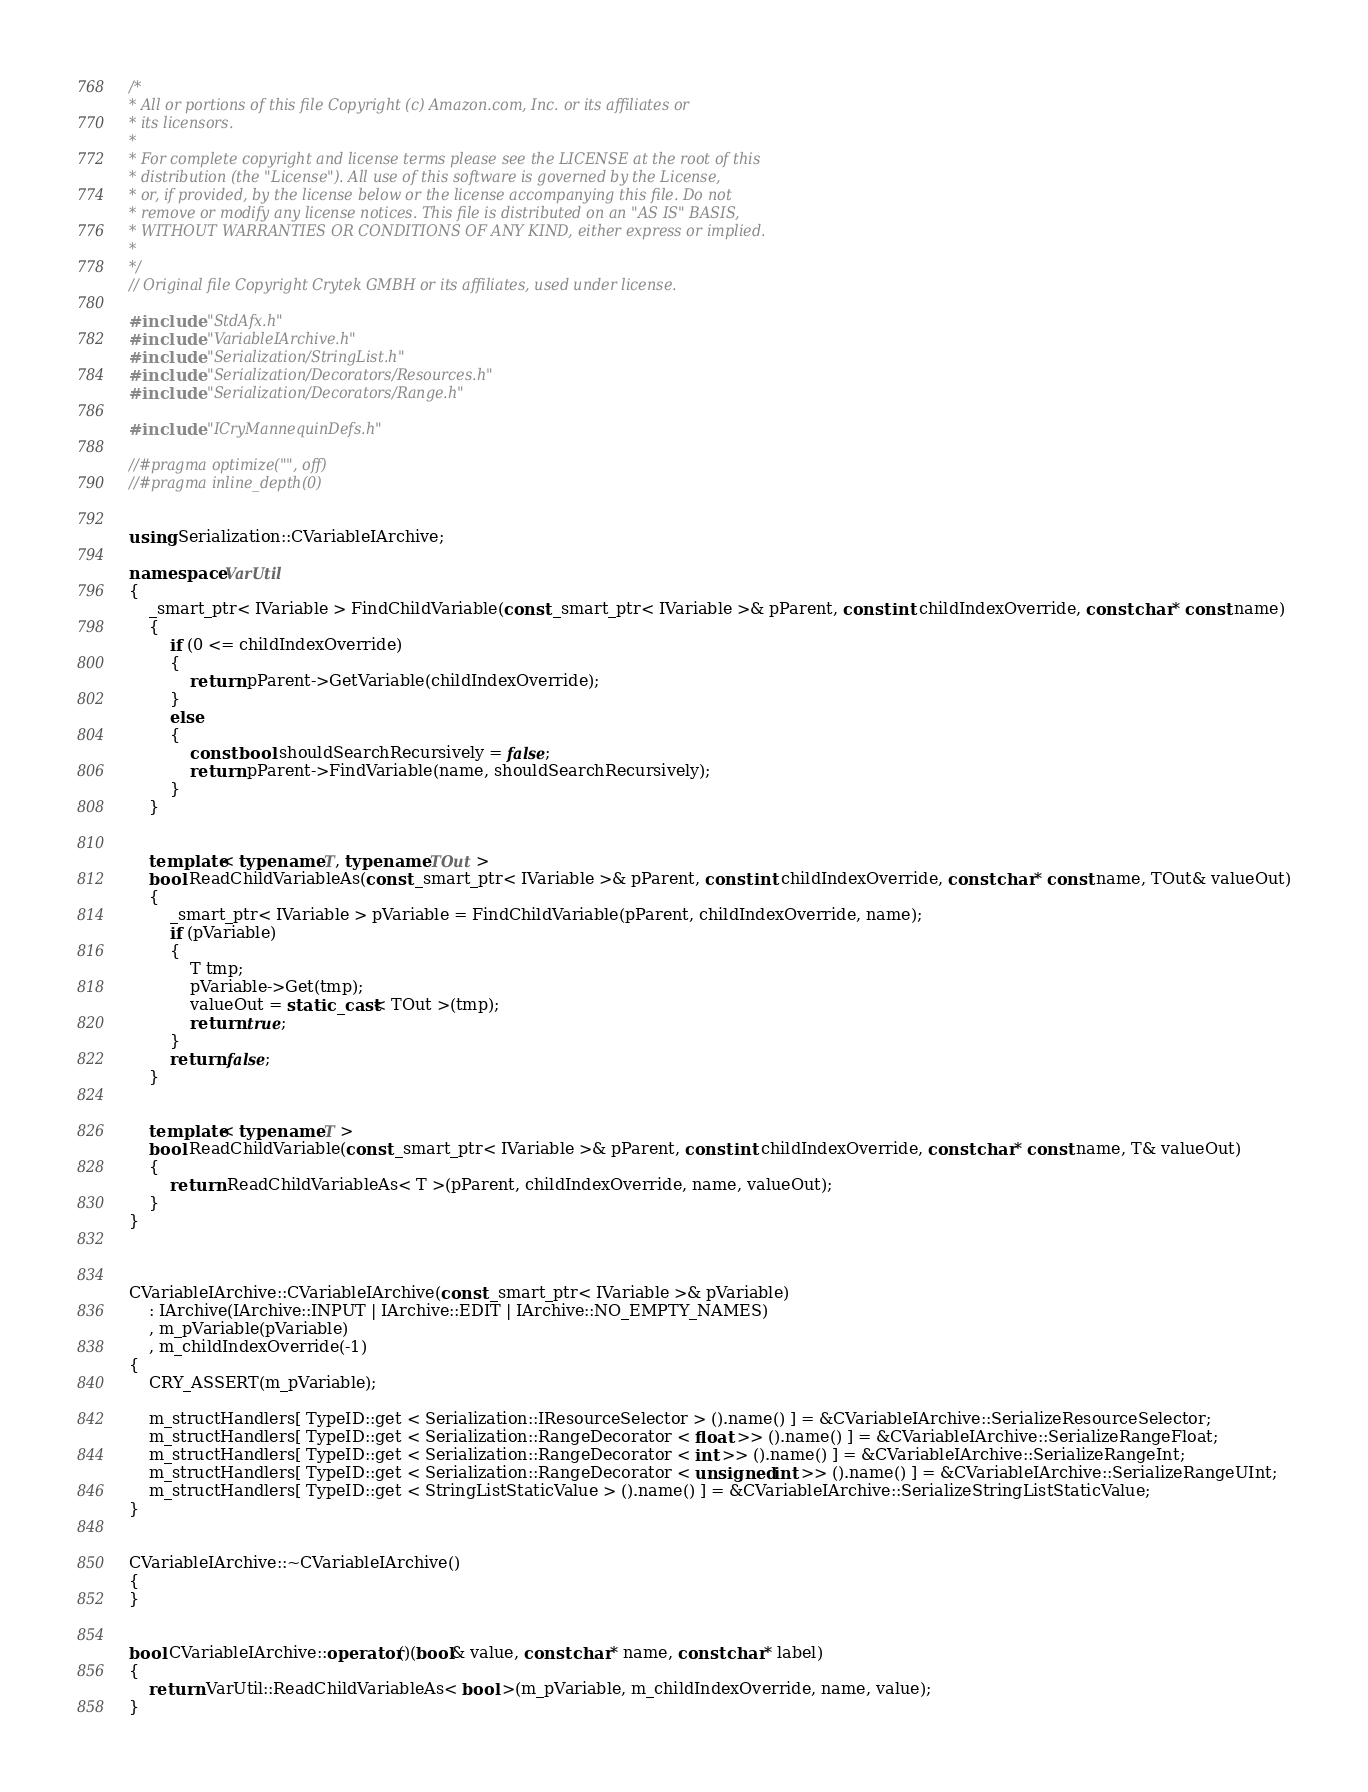<code> <loc_0><loc_0><loc_500><loc_500><_C++_>/*
* All or portions of this file Copyright (c) Amazon.com, Inc. or its affiliates or
* its licensors.
*
* For complete copyright and license terms please see the LICENSE at the root of this
* distribution (the "License"). All use of this software is governed by the License,
* or, if provided, by the license below or the license accompanying this file. Do not
* remove or modify any license notices. This file is distributed on an "AS IS" BASIS,
* WITHOUT WARRANTIES OR CONDITIONS OF ANY KIND, either express or implied.
*
*/
// Original file Copyright Crytek GMBH or its affiliates, used under license.

#include "StdAfx.h"
#include "VariableIArchive.h"
#include "Serialization/StringList.h"
#include "Serialization/Decorators/Resources.h"
#include "Serialization/Decorators/Range.h"

#include "ICryMannequinDefs.h"

//#pragma optimize("", off)
//#pragma inline_depth(0)


using Serialization::CVariableIArchive;

namespace VarUtil
{
    _smart_ptr< IVariable > FindChildVariable(const _smart_ptr< IVariable >& pParent, const int childIndexOverride, const char* const name)
    {
        if (0 <= childIndexOverride)
        {
            return pParent->GetVariable(childIndexOverride);
        }
        else
        {
            const bool shouldSearchRecursively = false;
            return pParent->FindVariable(name, shouldSearchRecursively);
        }
    }


    template< typename T, typename TOut >
    bool ReadChildVariableAs(const _smart_ptr< IVariable >& pParent, const int childIndexOverride, const char* const name, TOut& valueOut)
    {
        _smart_ptr< IVariable > pVariable = FindChildVariable(pParent, childIndexOverride, name);
        if (pVariable)
        {
            T tmp;
            pVariable->Get(tmp);
            valueOut = static_cast< TOut >(tmp);
            return true;
        }
        return false;
    }


    template< typename T >
    bool ReadChildVariable(const _smart_ptr< IVariable >& pParent, const int childIndexOverride, const char* const name, T& valueOut)
    {
        return ReadChildVariableAs< T >(pParent, childIndexOverride, name, valueOut);
    }
}



CVariableIArchive::CVariableIArchive(const _smart_ptr< IVariable >& pVariable)
    : IArchive(IArchive::INPUT | IArchive::EDIT | IArchive::NO_EMPTY_NAMES)
    , m_pVariable(pVariable)
    , m_childIndexOverride(-1)
{
    CRY_ASSERT(m_pVariable);

    m_structHandlers[ TypeID::get < Serialization::IResourceSelector > ().name() ] = &CVariableIArchive::SerializeResourceSelector;
    m_structHandlers[ TypeID::get < Serialization::RangeDecorator < float >> ().name() ] = &CVariableIArchive::SerializeRangeFloat;
    m_structHandlers[ TypeID::get < Serialization::RangeDecorator < int >> ().name() ] = &CVariableIArchive::SerializeRangeInt;
    m_structHandlers[ TypeID::get < Serialization::RangeDecorator < unsigned int >> ().name() ] = &CVariableIArchive::SerializeRangeUInt;
    m_structHandlers[ TypeID::get < StringListStaticValue > ().name() ] = &CVariableIArchive::SerializeStringListStaticValue;
}


CVariableIArchive::~CVariableIArchive()
{
}


bool CVariableIArchive::operator()(bool& value, const char* name, const char* label)
{
    return VarUtil::ReadChildVariableAs< bool >(m_pVariable, m_childIndexOverride, name, value);
}

</code> 